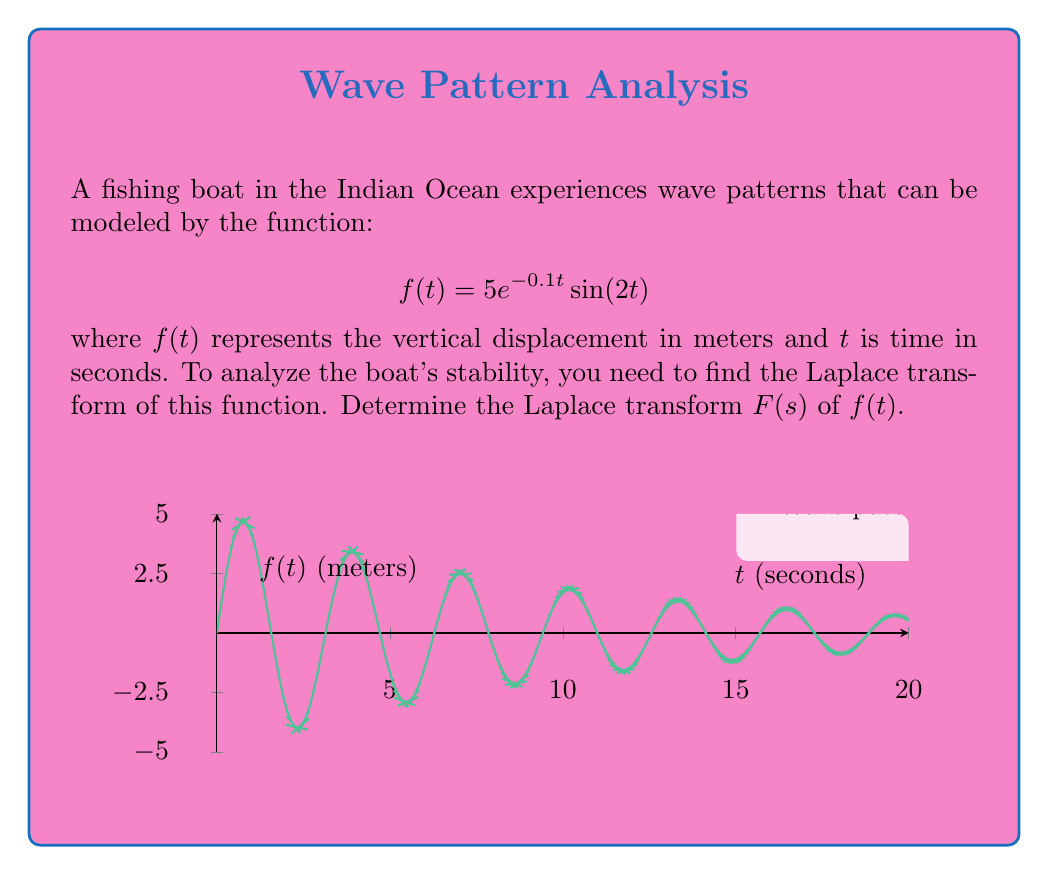Can you answer this question? To find the Laplace transform of $f(t) = 5e^{-0.1t}\sin(2t)$, we'll follow these steps:

1) Recall the Laplace transform of a damped sinusoidal function:
   $$\mathcal{L}\{e^{at}\sin(bt)\} = \frac{b}{(s-a)^2 + b^2}$$

2) In our case, $a = -0.1$ and $b = 2$. We also have a constant factor of 5.

3) Applying the Laplace transform:
   $$\begin{align}
   F(s) &= \mathcal{L}\{5e^{-0.1t}\sin(2t)\} \\
   &= 5 \cdot \mathcal{L}\{e^{-0.1t}\sin(2t)\} \\
   &= 5 \cdot \frac{2}{(s-(-0.1))^2 + 2^2}
   \end{align}$$

4) Simplify:
   $$\begin{align}
   F(s) &= 5 \cdot \frac{2}{(s+0.1)^2 + 4} \\
   &= \frac{10}{(s+0.1)^2 + 4}
   \end{align}$$

This final expression represents the Laplace transform of the given wave function, which can be used to analyze the boat's stability in the frequency domain.
Answer: $$F(s) = \frac{10}{(s+0.1)^2 + 4}$$ 